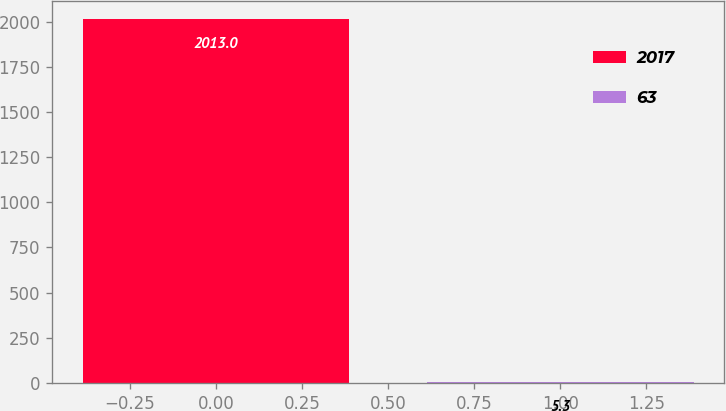<chart> <loc_0><loc_0><loc_500><loc_500><bar_chart><fcel>2017<fcel>63<nl><fcel>2013<fcel>5.3<nl></chart> 